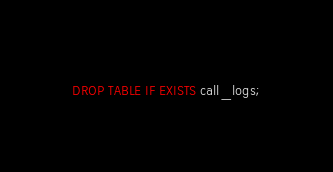Convert code to text. <code><loc_0><loc_0><loc_500><loc_500><_SQL_>DROP TABLE IF EXISTS call_logs;</code> 